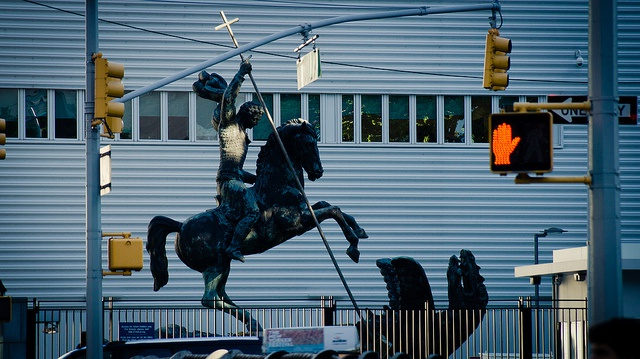Describe the objects in this image and their specific colors. I can see horse in darkblue, black, blue, and gray tones, people in darkblue, black, darkgray, and gray tones, traffic light in darkblue, black, red, and olive tones, traffic light in darkblue, olive, black, and tan tones, and traffic light in darkblue, olive, black, and maroon tones in this image. 